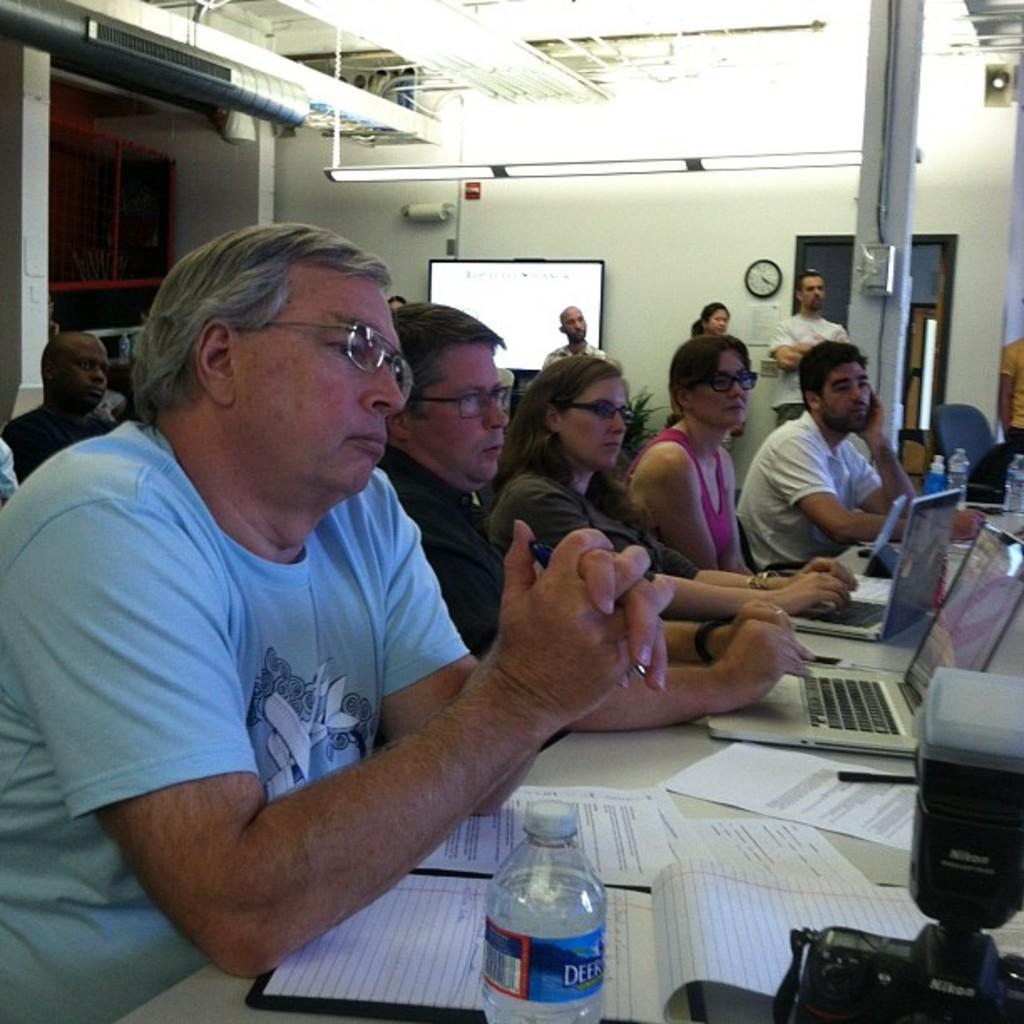How would you summarize this image in a sentence or two? These persons are sitting on a chair. In-front of this person there is a table, on a table there is a laptop, camera, bottle, papers and pen. These persons wore spectacles. A screen on wall. A clock on wall. On top there are lights. Far these persons are standing. 